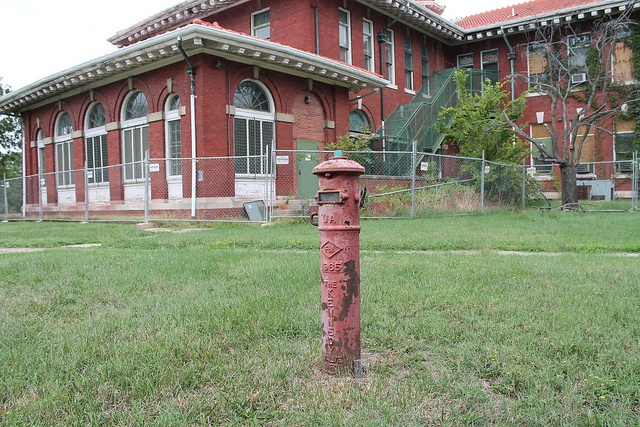Describe the objects in this image and their specific colors. I can see a fire hydrant in white, brown, gray, lightpink, and darkgray tones in this image. 